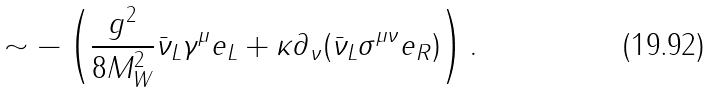Convert formula to latex. <formula><loc_0><loc_0><loc_500><loc_500>\sim - \left ( \frac { g ^ { 2 } } { 8 M ^ { 2 } _ { W } } \bar { \nu } _ { L } \gamma ^ { \mu } e _ { L } + \kappa \partial _ { \nu } ( \bar { \nu } _ { L } \sigma ^ { \mu \nu } e _ { R } ) \right ) .</formula> 